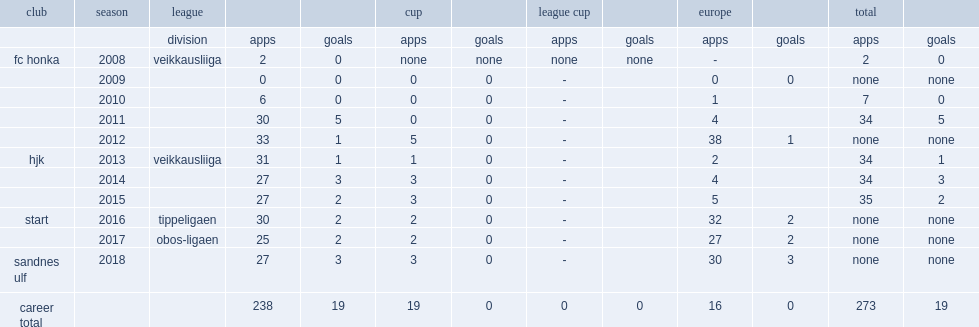Which club did heikkila play for in 2016? Start. 